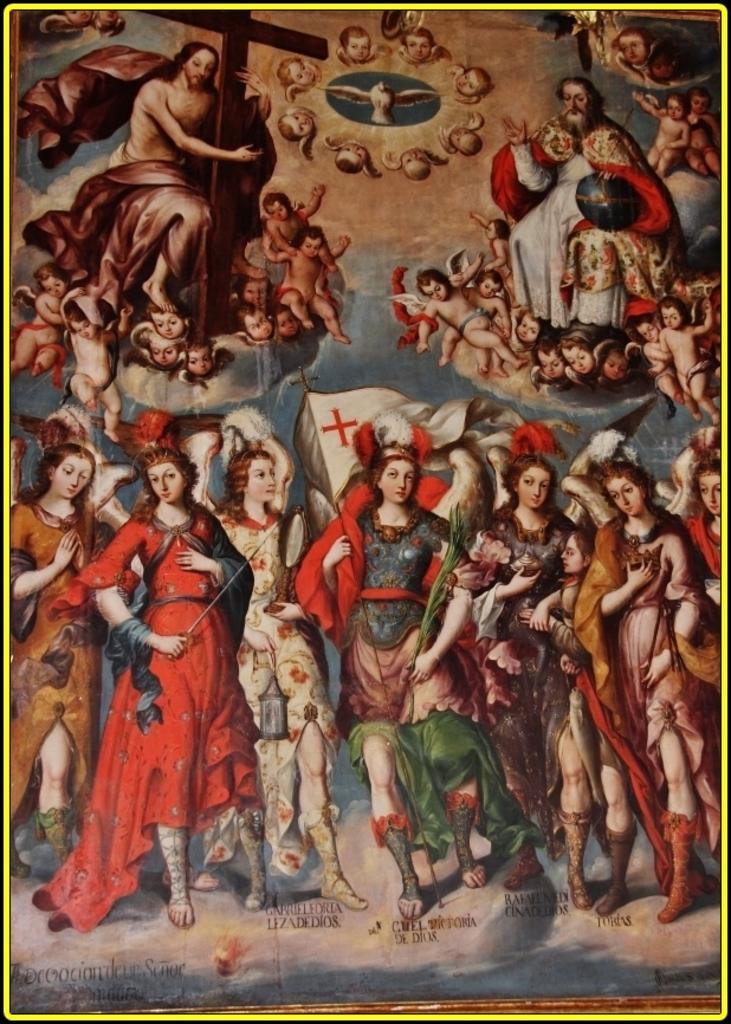Can you describe this image briefly? Here we can see poster,in this poster we can see persons and christian cross. 